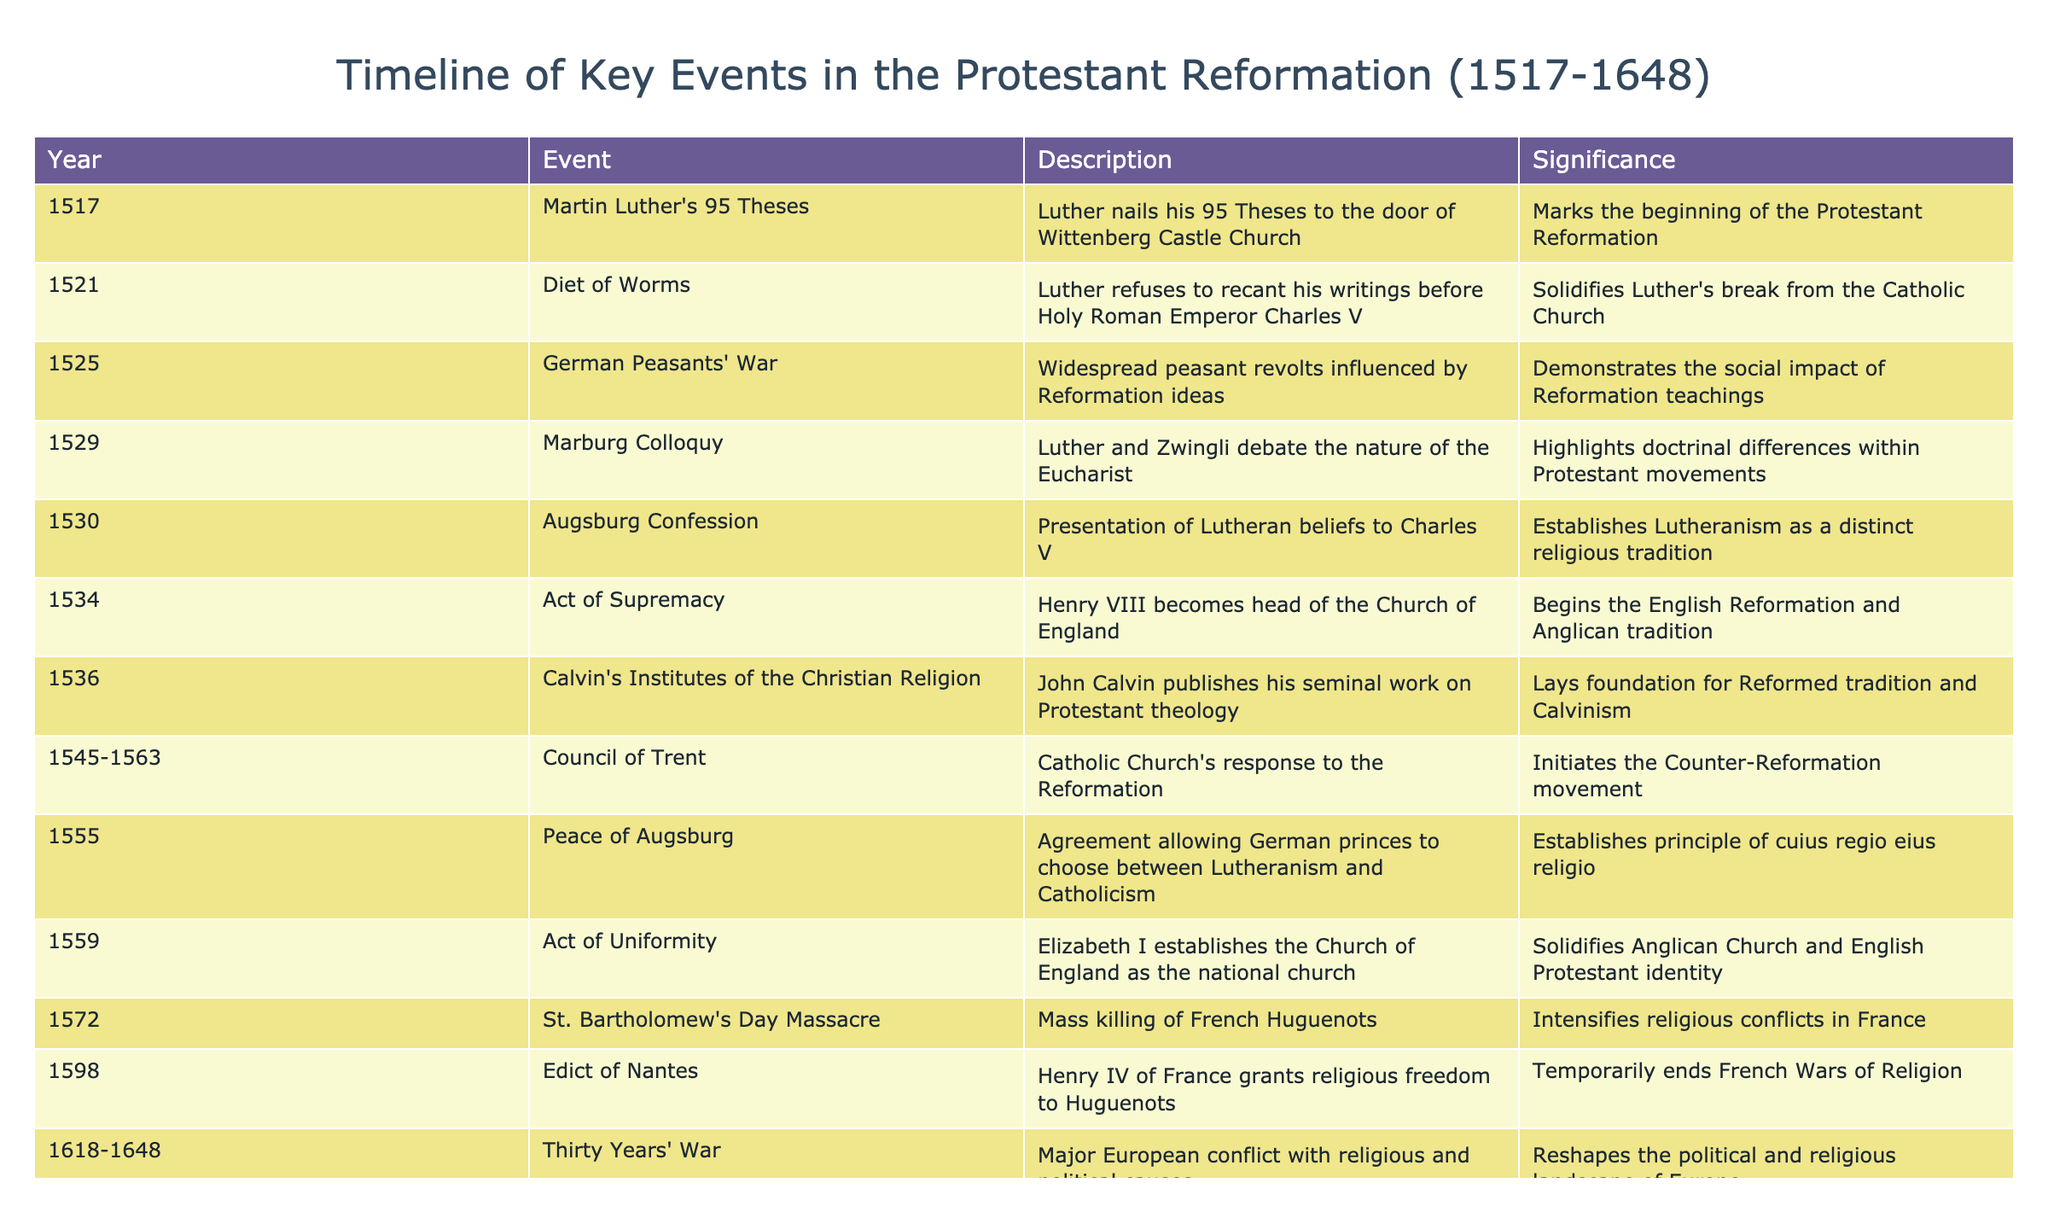What year did Martin Luther publish his 95 Theses? The table indicates that Martin Luther's 95 Theses were published in the year 1517. This is clearly presented as the first event in the timeline.
Answer: 1517 What significant event occurred in 1555? According to the table, the Peace of Augsburg took place in 1555, which allowed German princes to choose between Lutheranism and Catholicism.
Answer: Peace of Augsburg Was the Diet of Worms in 1521 significant for Luther's relationship with the Catholic Church? Yes, the Diet of Worms in 1521, where Luther refused to recant his writings, marks a pivotal point in his break from the Catholic Church, as highlighted in the description column.
Answer: Yes How many years passed between the 95 Theses and the Peace of Westphalia? The 95 Theses were in 1517, and the Peace of Westphalia was in 1648. The difference in years is 1648 - 1517 = 131 years.
Answer: 131 years Which event in 1545 initiated the Counter-Reformation movement? The event listed in the table for 1545 is the Council of Trent. It is described as the Catholic Church's response to the Reformation, marking the start of the Counter-Reformation.
Answer: Council of Trent What was the outcome of the Marburg Colloquy in 1529? The Marburg Colloquy in 1529 involved a debate between Luther and Zwingli about the nature of the Eucharist, which highlighted the doctrinal differences among Protestant movements according to the significance described in the table.
Answer: Doctrinal differences Which event established Lutheranism as a distinct religious tradition? The Augsburg Confession in 1530 is stated in the table as the presentation of Lutheran beliefs to Charles V, which confirms the establishment of Lutheranism.
Answer: Augsburg Confession Did the German Peasants' War of 1525 demonstrate any social impacts of Reformation teachings? Yes, the German Peasants' War was influenced by Reformation ideas, showcasing the social impact reflected in the description of the event in the table.
Answer: Yes How many events listed occurred in the 16th century? A total of 8 events from the table fall within the 16th century (1517 to 1599). They are from the years 1517, 1521, 1525, 1529, 1530, 1534, 1545-1563, 1555, 1559, and 1572. Thus, counting each gives a total of 8 events for the 16th century.
Answer: 8 events 